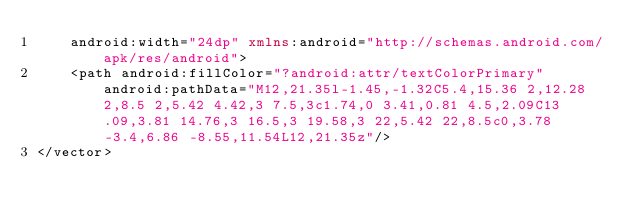Convert code to text. <code><loc_0><loc_0><loc_500><loc_500><_XML_>    android:width="24dp" xmlns:android="http://schemas.android.com/apk/res/android">
    <path android:fillColor="?android:attr/textColorPrimary" android:pathData="M12,21.35l-1.45,-1.32C5.4,15.36 2,12.28 2,8.5 2,5.42 4.42,3 7.5,3c1.74,0 3.41,0.81 4.5,2.09C13.09,3.81 14.76,3 16.5,3 19.58,3 22,5.42 22,8.5c0,3.78 -3.4,6.86 -8.55,11.54L12,21.35z"/>
</vector>
</code> 